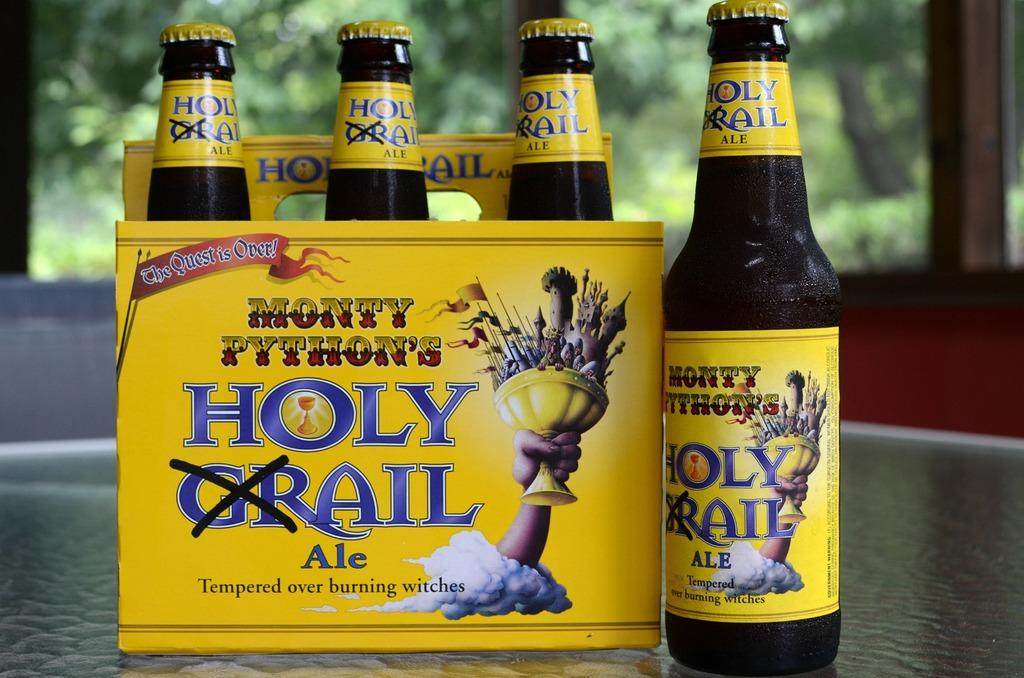<image>
Offer a succinct explanation of the picture presented. a yellow six pack of Holy Ail Ale 